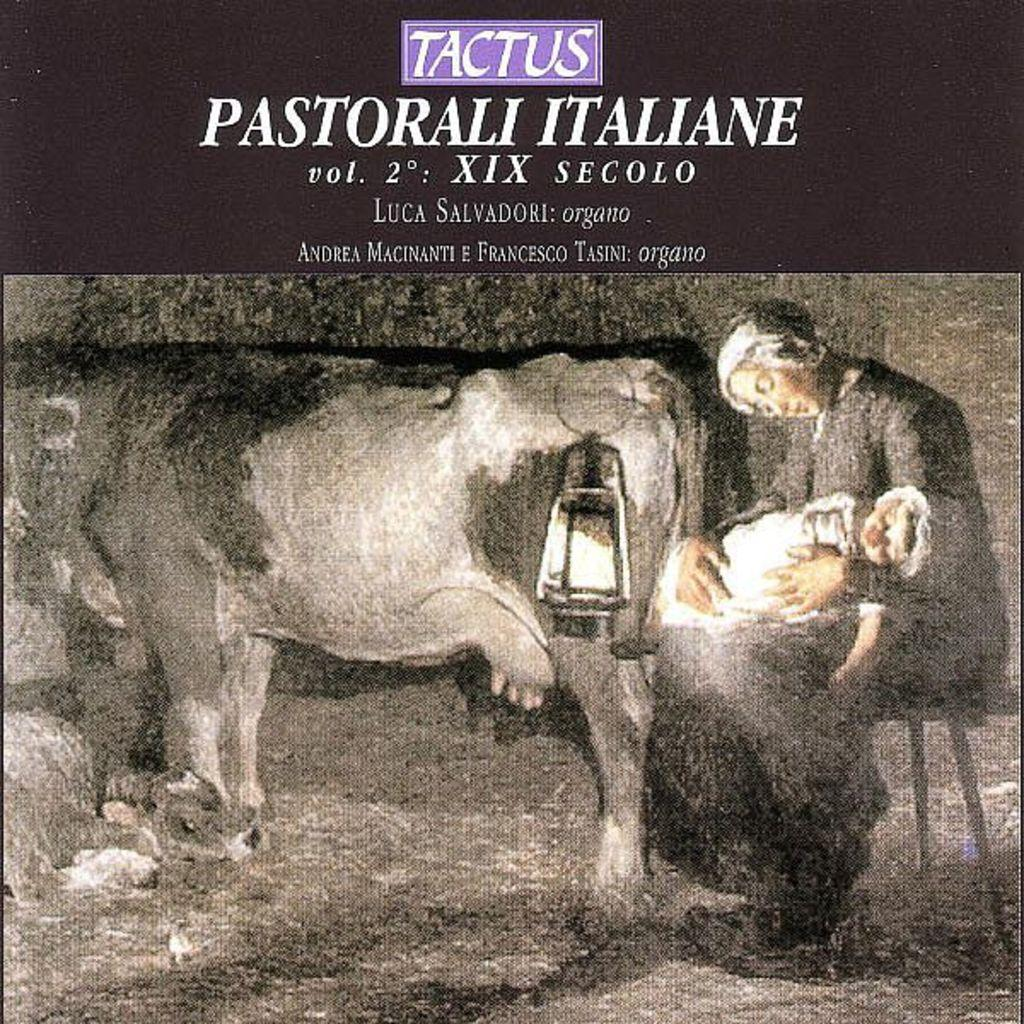What is featured on the poster in the image? The poster contains text and an image of a woman holding a baby. What other objects can be seen in the image? There is a lamp and a cow in the image. How many lizards are crawling on the cow in the image? There are no lizards present in the image, and therefore no such activity can be observed. What type of vase is placed on the table next to the lamp? There is no vase present in the image. 